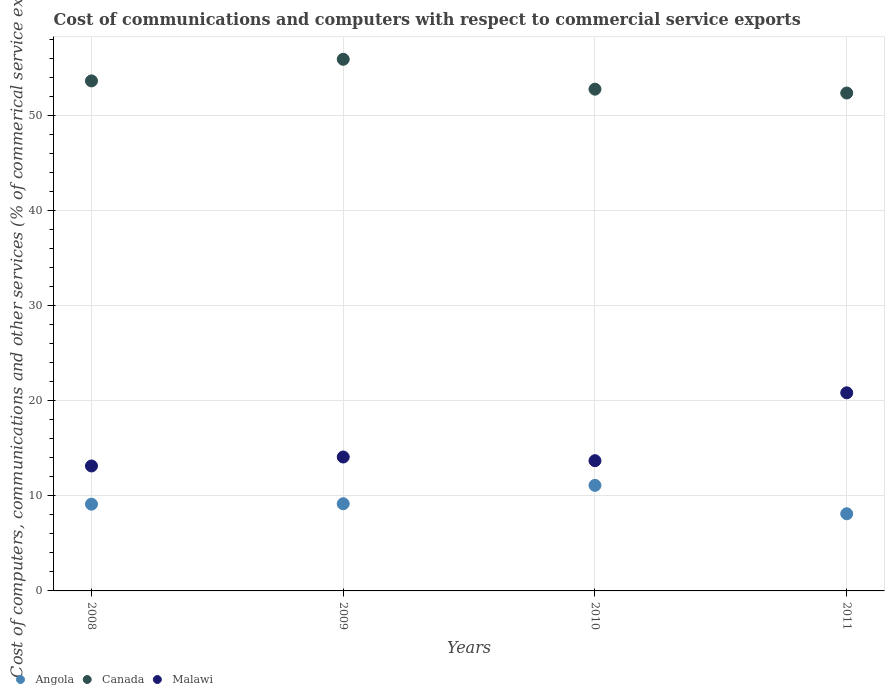How many different coloured dotlines are there?
Give a very brief answer. 3. Is the number of dotlines equal to the number of legend labels?
Keep it short and to the point. Yes. What is the cost of communications and computers in Malawi in 2008?
Your answer should be very brief. 13.14. Across all years, what is the maximum cost of communications and computers in Malawi?
Give a very brief answer. 20.83. Across all years, what is the minimum cost of communications and computers in Angola?
Offer a terse response. 8.11. In which year was the cost of communications and computers in Malawi minimum?
Offer a very short reply. 2008. What is the total cost of communications and computers in Malawi in the graph?
Your answer should be compact. 61.75. What is the difference between the cost of communications and computers in Canada in 2009 and that in 2010?
Offer a terse response. 3.14. What is the difference between the cost of communications and computers in Angola in 2011 and the cost of communications and computers in Canada in 2008?
Provide a short and direct response. -45.52. What is the average cost of communications and computers in Malawi per year?
Give a very brief answer. 15.44. In the year 2008, what is the difference between the cost of communications and computers in Canada and cost of communications and computers in Angola?
Provide a succinct answer. 44.51. What is the ratio of the cost of communications and computers in Angola in 2008 to that in 2011?
Ensure brevity in your answer.  1.12. Is the cost of communications and computers in Canada in 2008 less than that in 2010?
Your answer should be very brief. No. Is the difference between the cost of communications and computers in Canada in 2008 and 2009 greater than the difference between the cost of communications and computers in Angola in 2008 and 2009?
Your answer should be very brief. No. What is the difference between the highest and the second highest cost of communications and computers in Angola?
Offer a very short reply. 1.93. What is the difference between the highest and the lowest cost of communications and computers in Angola?
Provide a succinct answer. 2.98. In how many years, is the cost of communications and computers in Angola greater than the average cost of communications and computers in Angola taken over all years?
Make the answer very short. 1. Does the cost of communications and computers in Canada monotonically increase over the years?
Provide a succinct answer. No. What is the difference between two consecutive major ticks on the Y-axis?
Ensure brevity in your answer.  10. Are the values on the major ticks of Y-axis written in scientific E-notation?
Your answer should be very brief. No. Does the graph contain any zero values?
Provide a succinct answer. No. How are the legend labels stacked?
Provide a short and direct response. Horizontal. What is the title of the graph?
Make the answer very short. Cost of communications and computers with respect to commercial service exports. Does "Antigua and Barbuda" appear as one of the legend labels in the graph?
Provide a short and direct response. No. What is the label or title of the Y-axis?
Offer a very short reply. Cost of computers, communications and other services (% of commerical service exports). What is the Cost of computers, communications and other services (% of commerical service exports) of Angola in 2008?
Ensure brevity in your answer.  9.12. What is the Cost of computers, communications and other services (% of commerical service exports) of Canada in 2008?
Offer a very short reply. 53.63. What is the Cost of computers, communications and other services (% of commerical service exports) of Malawi in 2008?
Your answer should be compact. 13.14. What is the Cost of computers, communications and other services (% of commerical service exports) of Angola in 2009?
Keep it short and to the point. 9.17. What is the Cost of computers, communications and other services (% of commerical service exports) of Canada in 2009?
Give a very brief answer. 55.9. What is the Cost of computers, communications and other services (% of commerical service exports) of Malawi in 2009?
Your answer should be compact. 14.08. What is the Cost of computers, communications and other services (% of commerical service exports) in Angola in 2010?
Your answer should be compact. 11.1. What is the Cost of computers, communications and other services (% of commerical service exports) of Canada in 2010?
Offer a terse response. 52.76. What is the Cost of computers, communications and other services (% of commerical service exports) in Malawi in 2010?
Offer a terse response. 13.69. What is the Cost of computers, communications and other services (% of commerical service exports) in Angola in 2011?
Keep it short and to the point. 8.11. What is the Cost of computers, communications and other services (% of commerical service exports) in Canada in 2011?
Make the answer very short. 52.36. What is the Cost of computers, communications and other services (% of commerical service exports) in Malawi in 2011?
Give a very brief answer. 20.83. Across all years, what is the maximum Cost of computers, communications and other services (% of commerical service exports) of Angola?
Your response must be concise. 11.1. Across all years, what is the maximum Cost of computers, communications and other services (% of commerical service exports) of Canada?
Offer a very short reply. 55.9. Across all years, what is the maximum Cost of computers, communications and other services (% of commerical service exports) in Malawi?
Offer a very short reply. 20.83. Across all years, what is the minimum Cost of computers, communications and other services (% of commerical service exports) in Angola?
Ensure brevity in your answer.  8.11. Across all years, what is the minimum Cost of computers, communications and other services (% of commerical service exports) of Canada?
Provide a short and direct response. 52.36. Across all years, what is the minimum Cost of computers, communications and other services (% of commerical service exports) in Malawi?
Give a very brief answer. 13.14. What is the total Cost of computers, communications and other services (% of commerical service exports) in Angola in the graph?
Give a very brief answer. 37.5. What is the total Cost of computers, communications and other services (% of commerical service exports) in Canada in the graph?
Offer a very short reply. 214.66. What is the total Cost of computers, communications and other services (% of commerical service exports) of Malawi in the graph?
Offer a very short reply. 61.75. What is the difference between the Cost of computers, communications and other services (% of commerical service exports) in Angola in 2008 and that in 2009?
Ensure brevity in your answer.  -0.04. What is the difference between the Cost of computers, communications and other services (% of commerical service exports) of Canada in 2008 and that in 2009?
Provide a short and direct response. -2.27. What is the difference between the Cost of computers, communications and other services (% of commerical service exports) of Malawi in 2008 and that in 2009?
Provide a succinct answer. -0.94. What is the difference between the Cost of computers, communications and other services (% of commerical service exports) of Angola in 2008 and that in 2010?
Your answer should be compact. -1.98. What is the difference between the Cost of computers, communications and other services (% of commerical service exports) of Canada in 2008 and that in 2010?
Keep it short and to the point. 0.87. What is the difference between the Cost of computers, communications and other services (% of commerical service exports) of Malawi in 2008 and that in 2010?
Your answer should be very brief. -0.55. What is the difference between the Cost of computers, communications and other services (% of commerical service exports) in Angola in 2008 and that in 2011?
Your answer should be very brief. 1.01. What is the difference between the Cost of computers, communications and other services (% of commerical service exports) of Canada in 2008 and that in 2011?
Provide a short and direct response. 1.27. What is the difference between the Cost of computers, communications and other services (% of commerical service exports) of Malawi in 2008 and that in 2011?
Give a very brief answer. -7.69. What is the difference between the Cost of computers, communications and other services (% of commerical service exports) in Angola in 2009 and that in 2010?
Give a very brief answer. -1.93. What is the difference between the Cost of computers, communications and other services (% of commerical service exports) of Canada in 2009 and that in 2010?
Offer a terse response. 3.14. What is the difference between the Cost of computers, communications and other services (% of commerical service exports) in Malawi in 2009 and that in 2010?
Your answer should be compact. 0.39. What is the difference between the Cost of computers, communications and other services (% of commerical service exports) in Angola in 2009 and that in 2011?
Provide a short and direct response. 1.05. What is the difference between the Cost of computers, communications and other services (% of commerical service exports) of Canada in 2009 and that in 2011?
Give a very brief answer. 3.55. What is the difference between the Cost of computers, communications and other services (% of commerical service exports) in Malawi in 2009 and that in 2011?
Give a very brief answer. -6.75. What is the difference between the Cost of computers, communications and other services (% of commerical service exports) in Angola in 2010 and that in 2011?
Offer a terse response. 2.98. What is the difference between the Cost of computers, communications and other services (% of commerical service exports) in Canada in 2010 and that in 2011?
Provide a short and direct response. 0.41. What is the difference between the Cost of computers, communications and other services (% of commerical service exports) of Malawi in 2010 and that in 2011?
Provide a short and direct response. -7.14. What is the difference between the Cost of computers, communications and other services (% of commerical service exports) of Angola in 2008 and the Cost of computers, communications and other services (% of commerical service exports) of Canada in 2009?
Give a very brief answer. -46.78. What is the difference between the Cost of computers, communications and other services (% of commerical service exports) of Angola in 2008 and the Cost of computers, communications and other services (% of commerical service exports) of Malawi in 2009?
Offer a terse response. -4.96. What is the difference between the Cost of computers, communications and other services (% of commerical service exports) of Canada in 2008 and the Cost of computers, communications and other services (% of commerical service exports) of Malawi in 2009?
Ensure brevity in your answer.  39.55. What is the difference between the Cost of computers, communications and other services (% of commerical service exports) in Angola in 2008 and the Cost of computers, communications and other services (% of commerical service exports) in Canada in 2010?
Provide a succinct answer. -43.64. What is the difference between the Cost of computers, communications and other services (% of commerical service exports) in Angola in 2008 and the Cost of computers, communications and other services (% of commerical service exports) in Malawi in 2010?
Your answer should be very brief. -4.57. What is the difference between the Cost of computers, communications and other services (% of commerical service exports) of Canada in 2008 and the Cost of computers, communications and other services (% of commerical service exports) of Malawi in 2010?
Offer a terse response. 39.94. What is the difference between the Cost of computers, communications and other services (% of commerical service exports) of Angola in 2008 and the Cost of computers, communications and other services (% of commerical service exports) of Canada in 2011?
Offer a very short reply. -43.24. What is the difference between the Cost of computers, communications and other services (% of commerical service exports) in Angola in 2008 and the Cost of computers, communications and other services (% of commerical service exports) in Malawi in 2011?
Offer a very short reply. -11.71. What is the difference between the Cost of computers, communications and other services (% of commerical service exports) in Canada in 2008 and the Cost of computers, communications and other services (% of commerical service exports) in Malawi in 2011?
Offer a terse response. 32.8. What is the difference between the Cost of computers, communications and other services (% of commerical service exports) in Angola in 2009 and the Cost of computers, communications and other services (% of commerical service exports) in Canada in 2010?
Provide a short and direct response. -43.6. What is the difference between the Cost of computers, communications and other services (% of commerical service exports) in Angola in 2009 and the Cost of computers, communications and other services (% of commerical service exports) in Malawi in 2010?
Make the answer very short. -4.53. What is the difference between the Cost of computers, communications and other services (% of commerical service exports) of Canada in 2009 and the Cost of computers, communications and other services (% of commerical service exports) of Malawi in 2010?
Your answer should be compact. 42.21. What is the difference between the Cost of computers, communications and other services (% of commerical service exports) of Angola in 2009 and the Cost of computers, communications and other services (% of commerical service exports) of Canada in 2011?
Ensure brevity in your answer.  -43.19. What is the difference between the Cost of computers, communications and other services (% of commerical service exports) in Angola in 2009 and the Cost of computers, communications and other services (% of commerical service exports) in Malawi in 2011?
Make the answer very short. -11.67. What is the difference between the Cost of computers, communications and other services (% of commerical service exports) of Canada in 2009 and the Cost of computers, communications and other services (% of commerical service exports) of Malawi in 2011?
Offer a terse response. 35.07. What is the difference between the Cost of computers, communications and other services (% of commerical service exports) in Angola in 2010 and the Cost of computers, communications and other services (% of commerical service exports) in Canada in 2011?
Make the answer very short. -41.26. What is the difference between the Cost of computers, communications and other services (% of commerical service exports) of Angola in 2010 and the Cost of computers, communications and other services (% of commerical service exports) of Malawi in 2011?
Your answer should be very brief. -9.73. What is the difference between the Cost of computers, communications and other services (% of commerical service exports) in Canada in 2010 and the Cost of computers, communications and other services (% of commerical service exports) in Malawi in 2011?
Provide a succinct answer. 31.93. What is the average Cost of computers, communications and other services (% of commerical service exports) in Angola per year?
Give a very brief answer. 9.38. What is the average Cost of computers, communications and other services (% of commerical service exports) of Canada per year?
Your answer should be compact. 53.66. What is the average Cost of computers, communications and other services (% of commerical service exports) in Malawi per year?
Provide a succinct answer. 15.44. In the year 2008, what is the difference between the Cost of computers, communications and other services (% of commerical service exports) in Angola and Cost of computers, communications and other services (% of commerical service exports) in Canada?
Provide a short and direct response. -44.51. In the year 2008, what is the difference between the Cost of computers, communications and other services (% of commerical service exports) in Angola and Cost of computers, communications and other services (% of commerical service exports) in Malawi?
Your answer should be very brief. -4.02. In the year 2008, what is the difference between the Cost of computers, communications and other services (% of commerical service exports) of Canada and Cost of computers, communications and other services (% of commerical service exports) of Malawi?
Ensure brevity in your answer.  40.49. In the year 2009, what is the difference between the Cost of computers, communications and other services (% of commerical service exports) in Angola and Cost of computers, communications and other services (% of commerical service exports) in Canada?
Give a very brief answer. -46.74. In the year 2009, what is the difference between the Cost of computers, communications and other services (% of commerical service exports) of Angola and Cost of computers, communications and other services (% of commerical service exports) of Malawi?
Your response must be concise. -4.92. In the year 2009, what is the difference between the Cost of computers, communications and other services (% of commerical service exports) of Canada and Cost of computers, communications and other services (% of commerical service exports) of Malawi?
Keep it short and to the point. 41.82. In the year 2010, what is the difference between the Cost of computers, communications and other services (% of commerical service exports) in Angola and Cost of computers, communications and other services (% of commerical service exports) in Canada?
Give a very brief answer. -41.66. In the year 2010, what is the difference between the Cost of computers, communications and other services (% of commerical service exports) in Angola and Cost of computers, communications and other services (% of commerical service exports) in Malawi?
Keep it short and to the point. -2.59. In the year 2010, what is the difference between the Cost of computers, communications and other services (% of commerical service exports) of Canada and Cost of computers, communications and other services (% of commerical service exports) of Malawi?
Provide a succinct answer. 39.07. In the year 2011, what is the difference between the Cost of computers, communications and other services (% of commerical service exports) in Angola and Cost of computers, communications and other services (% of commerical service exports) in Canada?
Give a very brief answer. -44.24. In the year 2011, what is the difference between the Cost of computers, communications and other services (% of commerical service exports) in Angola and Cost of computers, communications and other services (% of commerical service exports) in Malawi?
Your answer should be very brief. -12.72. In the year 2011, what is the difference between the Cost of computers, communications and other services (% of commerical service exports) of Canada and Cost of computers, communications and other services (% of commerical service exports) of Malawi?
Provide a succinct answer. 31.53. What is the ratio of the Cost of computers, communications and other services (% of commerical service exports) of Angola in 2008 to that in 2009?
Your answer should be compact. 1. What is the ratio of the Cost of computers, communications and other services (% of commerical service exports) of Canada in 2008 to that in 2009?
Your answer should be compact. 0.96. What is the ratio of the Cost of computers, communications and other services (% of commerical service exports) in Malawi in 2008 to that in 2009?
Give a very brief answer. 0.93. What is the ratio of the Cost of computers, communications and other services (% of commerical service exports) of Angola in 2008 to that in 2010?
Offer a terse response. 0.82. What is the ratio of the Cost of computers, communications and other services (% of commerical service exports) in Canada in 2008 to that in 2010?
Your response must be concise. 1.02. What is the ratio of the Cost of computers, communications and other services (% of commerical service exports) in Malawi in 2008 to that in 2010?
Offer a terse response. 0.96. What is the ratio of the Cost of computers, communications and other services (% of commerical service exports) of Angola in 2008 to that in 2011?
Offer a terse response. 1.12. What is the ratio of the Cost of computers, communications and other services (% of commerical service exports) of Canada in 2008 to that in 2011?
Provide a succinct answer. 1.02. What is the ratio of the Cost of computers, communications and other services (% of commerical service exports) of Malawi in 2008 to that in 2011?
Provide a short and direct response. 0.63. What is the ratio of the Cost of computers, communications and other services (% of commerical service exports) in Angola in 2009 to that in 2010?
Your answer should be very brief. 0.83. What is the ratio of the Cost of computers, communications and other services (% of commerical service exports) of Canada in 2009 to that in 2010?
Ensure brevity in your answer.  1.06. What is the ratio of the Cost of computers, communications and other services (% of commerical service exports) of Malawi in 2009 to that in 2010?
Keep it short and to the point. 1.03. What is the ratio of the Cost of computers, communications and other services (% of commerical service exports) of Angola in 2009 to that in 2011?
Ensure brevity in your answer.  1.13. What is the ratio of the Cost of computers, communications and other services (% of commerical service exports) in Canada in 2009 to that in 2011?
Make the answer very short. 1.07. What is the ratio of the Cost of computers, communications and other services (% of commerical service exports) in Malawi in 2009 to that in 2011?
Ensure brevity in your answer.  0.68. What is the ratio of the Cost of computers, communications and other services (% of commerical service exports) of Angola in 2010 to that in 2011?
Give a very brief answer. 1.37. What is the ratio of the Cost of computers, communications and other services (% of commerical service exports) of Canada in 2010 to that in 2011?
Make the answer very short. 1.01. What is the ratio of the Cost of computers, communications and other services (% of commerical service exports) in Malawi in 2010 to that in 2011?
Make the answer very short. 0.66. What is the difference between the highest and the second highest Cost of computers, communications and other services (% of commerical service exports) in Angola?
Give a very brief answer. 1.93. What is the difference between the highest and the second highest Cost of computers, communications and other services (% of commerical service exports) in Canada?
Your response must be concise. 2.27. What is the difference between the highest and the second highest Cost of computers, communications and other services (% of commerical service exports) of Malawi?
Your answer should be very brief. 6.75. What is the difference between the highest and the lowest Cost of computers, communications and other services (% of commerical service exports) in Angola?
Ensure brevity in your answer.  2.98. What is the difference between the highest and the lowest Cost of computers, communications and other services (% of commerical service exports) in Canada?
Your answer should be very brief. 3.55. What is the difference between the highest and the lowest Cost of computers, communications and other services (% of commerical service exports) in Malawi?
Your response must be concise. 7.69. 